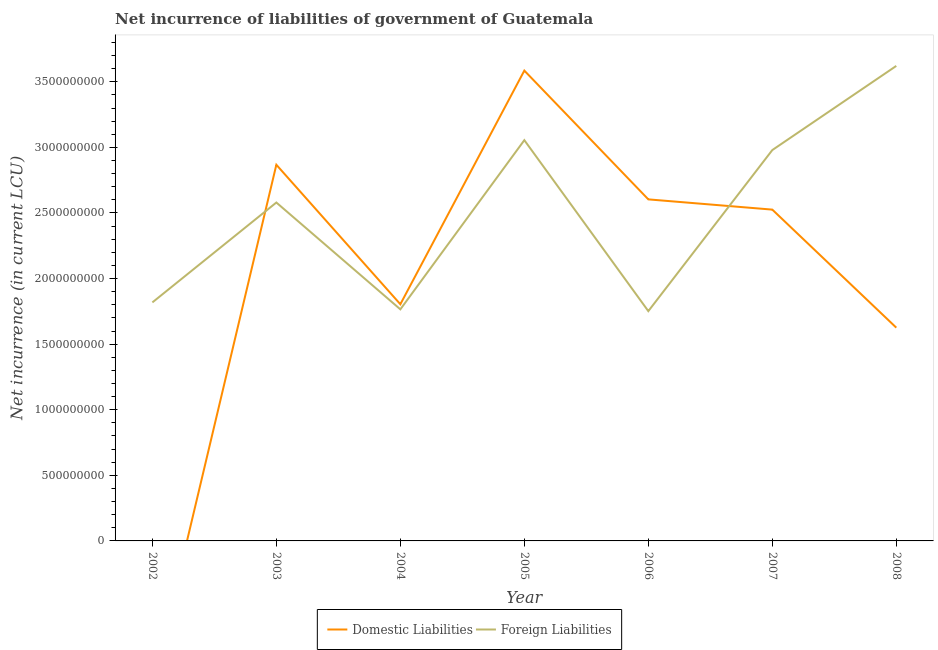How many different coloured lines are there?
Offer a terse response. 2. Does the line corresponding to net incurrence of domestic liabilities intersect with the line corresponding to net incurrence of foreign liabilities?
Make the answer very short. Yes. What is the net incurrence of foreign liabilities in 2005?
Offer a terse response. 3.05e+09. Across all years, what is the maximum net incurrence of domestic liabilities?
Provide a short and direct response. 3.58e+09. Across all years, what is the minimum net incurrence of domestic liabilities?
Your answer should be very brief. 0. In which year was the net incurrence of domestic liabilities maximum?
Your answer should be very brief. 2005. What is the total net incurrence of foreign liabilities in the graph?
Give a very brief answer. 1.76e+1. What is the difference between the net incurrence of domestic liabilities in 2005 and that in 2007?
Provide a short and direct response. 1.06e+09. What is the difference between the net incurrence of foreign liabilities in 2004 and the net incurrence of domestic liabilities in 2005?
Offer a terse response. -1.82e+09. What is the average net incurrence of domestic liabilities per year?
Provide a short and direct response. 2.14e+09. In the year 2003, what is the difference between the net incurrence of domestic liabilities and net incurrence of foreign liabilities?
Offer a very short reply. 2.88e+08. In how many years, is the net incurrence of foreign liabilities greater than 2700000000 LCU?
Make the answer very short. 3. What is the ratio of the net incurrence of domestic liabilities in 2004 to that in 2005?
Make the answer very short. 0.5. Is the net incurrence of foreign liabilities in 2004 less than that in 2006?
Give a very brief answer. No. Is the difference between the net incurrence of domestic liabilities in 2004 and 2007 greater than the difference between the net incurrence of foreign liabilities in 2004 and 2007?
Make the answer very short. Yes. What is the difference between the highest and the second highest net incurrence of domestic liabilities?
Provide a succinct answer. 7.18e+08. What is the difference between the highest and the lowest net incurrence of domestic liabilities?
Your answer should be compact. 3.58e+09. In how many years, is the net incurrence of domestic liabilities greater than the average net incurrence of domestic liabilities taken over all years?
Your answer should be very brief. 4. Is the net incurrence of domestic liabilities strictly less than the net incurrence of foreign liabilities over the years?
Your answer should be very brief. No. How many years are there in the graph?
Provide a succinct answer. 7. Does the graph contain any zero values?
Provide a short and direct response. Yes. Does the graph contain grids?
Provide a short and direct response. No. Where does the legend appear in the graph?
Your answer should be very brief. Bottom center. How many legend labels are there?
Keep it short and to the point. 2. How are the legend labels stacked?
Your answer should be very brief. Horizontal. What is the title of the graph?
Your answer should be compact. Net incurrence of liabilities of government of Guatemala. Does "Goods and services" appear as one of the legend labels in the graph?
Make the answer very short. No. What is the label or title of the X-axis?
Keep it short and to the point. Year. What is the label or title of the Y-axis?
Provide a succinct answer. Net incurrence (in current LCU). What is the Net incurrence (in current LCU) in Foreign Liabilities in 2002?
Your answer should be very brief. 1.82e+09. What is the Net incurrence (in current LCU) of Domestic Liabilities in 2003?
Offer a terse response. 2.87e+09. What is the Net incurrence (in current LCU) in Foreign Liabilities in 2003?
Provide a short and direct response. 2.58e+09. What is the Net incurrence (in current LCU) of Domestic Liabilities in 2004?
Your answer should be compact. 1.80e+09. What is the Net incurrence (in current LCU) in Foreign Liabilities in 2004?
Offer a terse response. 1.77e+09. What is the Net incurrence (in current LCU) of Domestic Liabilities in 2005?
Offer a very short reply. 3.58e+09. What is the Net incurrence (in current LCU) in Foreign Liabilities in 2005?
Offer a very short reply. 3.05e+09. What is the Net incurrence (in current LCU) in Domestic Liabilities in 2006?
Your response must be concise. 2.60e+09. What is the Net incurrence (in current LCU) in Foreign Liabilities in 2006?
Your response must be concise. 1.75e+09. What is the Net incurrence (in current LCU) of Domestic Liabilities in 2007?
Keep it short and to the point. 2.53e+09. What is the Net incurrence (in current LCU) in Foreign Liabilities in 2007?
Offer a very short reply. 2.98e+09. What is the Net incurrence (in current LCU) of Domestic Liabilities in 2008?
Your response must be concise. 1.63e+09. What is the Net incurrence (in current LCU) of Foreign Liabilities in 2008?
Offer a terse response. 3.62e+09. Across all years, what is the maximum Net incurrence (in current LCU) in Domestic Liabilities?
Your answer should be compact. 3.58e+09. Across all years, what is the maximum Net incurrence (in current LCU) in Foreign Liabilities?
Offer a terse response. 3.62e+09. Across all years, what is the minimum Net incurrence (in current LCU) in Foreign Liabilities?
Give a very brief answer. 1.75e+09. What is the total Net incurrence (in current LCU) in Domestic Liabilities in the graph?
Provide a succinct answer. 1.50e+1. What is the total Net incurrence (in current LCU) of Foreign Liabilities in the graph?
Offer a very short reply. 1.76e+1. What is the difference between the Net incurrence (in current LCU) in Foreign Liabilities in 2002 and that in 2003?
Keep it short and to the point. -7.61e+08. What is the difference between the Net incurrence (in current LCU) in Foreign Liabilities in 2002 and that in 2004?
Offer a very short reply. 5.28e+07. What is the difference between the Net incurrence (in current LCU) of Foreign Liabilities in 2002 and that in 2005?
Offer a terse response. -1.24e+09. What is the difference between the Net incurrence (in current LCU) of Foreign Liabilities in 2002 and that in 2006?
Your response must be concise. 6.65e+07. What is the difference between the Net incurrence (in current LCU) of Foreign Liabilities in 2002 and that in 2007?
Your answer should be compact. -1.16e+09. What is the difference between the Net incurrence (in current LCU) in Foreign Liabilities in 2002 and that in 2008?
Your answer should be compact. -1.80e+09. What is the difference between the Net incurrence (in current LCU) of Domestic Liabilities in 2003 and that in 2004?
Your response must be concise. 1.06e+09. What is the difference between the Net incurrence (in current LCU) of Foreign Liabilities in 2003 and that in 2004?
Your answer should be very brief. 8.14e+08. What is the difference between the Net incurrence (in current LCU) of Domestic Liabilities in 2003 and that in 2005?
Give a very brief answer. -7.18e+08. What is the difference between the Net incurrence (in current LCU) in Foreign Liabilities in 2003 and that in 2005?
Make the answer very short. -4.75e+08. What is the difference between the Net incurrence (in current LCU) of Domestic Liabilities in 2003 and that in 2006?
Your answer should be compact. 2.64e+08. What is the difference between the Net incurrence (in current LCU) in Foreign Liabilities in 2003 and that in 2006?
Provide a succinct answer. 8.28e+08. What is the difference between the Net incurrence (in current LCU) in Domestic Liabilities in 2003 and that in 2007?
Your response must be concise. 3.42e+08. What is the difference between the Net incurrence (in current LCU) of Foreign Liabilities in 2003 and that in 2007?
Your answer should be compact. -4.00e+08. What is the difference between the Net incurrence (in current LCU) in Domestic Liabilities in 2003 and that in 2008?
Your response must be concise. 1.24e+09. What is the difference between the Net incurrence (in current LCU) of Foreign Liabilities in 2003 and that in 2008?
Provide a short and direct response. -1.04e+09. What is the difference between the Net incurrence (in current LCU) in Domestic Liabilities in 2004 and that in 2005?
Give a very brief answer. -1.78e+09. What is the difference between the Net incurrence (in current LCU) in Foreign Liabilities in 2004 and that in 2005?
Provide a short and direct response. -1.29e+09. What is the difference between the Net incurrence (in current LCU) in Domestic Liabilities in 2004 and that in 2006?
Ensure brevity in your answer.  -7.99e+08. What is the difference between the Net incurrence (in current LCU) of Foreign Liabilities in 2004 and that in 2006?
Offer a terse response. 1.36e+07. What is the difference between the Net incurrence (in current LCU) in Domestic Liabilities in 2004 and that in 2007?
Provide a short and direct response. -7.21e+08. What is the difference between the Net incurrence (in current LCU) of Foreign Liabilities in 2004 and that in 2007?
Make the answer very short. -1.21e+09. What is the difference between the Net incurrence (in current LCU) of Domestic Liabilities in 2004 and that in 2008?
Provide a short and direct response. 1.79e+08. What is the difference between the Net incurrence (in current LCU) in Foreign Liabilities in 2004 and that in 2008?
Offer a very short reply. -1.86e+09. What is the difference between the Net incurrence (in current LCU) of Domestic Liabilities in 2005 and that in 2006?
Ensure brevity in your answer.  9.82e+08. What is the difference between the Net incurrence (in current LCU) of Foreign Liabilities in 2005 and that in 2006?
Ensure brevity in your answer.  1.30e+09. What is the difference between the Net incurrence (in current LCU) of Domestic Liabilities in 2005 and that in 2007?
Your answer should be very brief. 1.06e+09. What is the difference between the Net incurrence (in current LCU) in Foreign Liabilities in 2005 and that in 2007?
Your response must be concise. 7.54e+07. What is the difference between the Net incurrence (in current LCU) in Domestic Liabilities in 2005 and that in 2008?
Your answer should be compact. 1.96e+09. What is the difference between the Net incurrence (in current LCU) in Foreign Liabilities in 2005 and that in 2008?
Make the answer very short. -5.66e+08. What is the difference between the Net incurrence (in current LCU) in Domestic Liabilities in 2006 and that in 2007?
Your answer should be compact. 7.81e+07. What is the difference between the Net incurrence (in current LCU) in Foreign Liabilities in 2006 and that in 2007?
Your response must be concise. -1.23e+09. What is the difference between the Net incurrence (in current LCU) of Domestic Liabilities in 2006 and that in 2008?
Make the answer very short. 9.78e+08. What is the difference between the Net incurrence (in current LCU) in Foreign Liabilities in 2006 and that in 2008?
Provide a succinct answer. -1.87e+09. What is the difference between the Net incurrence (in current LCU) in Domestic Liabilities in 2007 and that in 2008?
Give a very brief answer. 9.00e+08. What is the difference between the Net incurrence (in current LCU) of Foreign Liabilities in 2007 and that in 2008?
Keep it short and to the point. -6.41e+08. What is the difference between the Net incurrence (in current LCU) of Domestic Liabilities in 2003 and the Net incurrence (in current LCU) of Foreign Liabilities in 2004?
Your answer should be very brief. 1.10e+09. What is the difference between the Net incurrence (in current LCU) of Domestic Liabilities in 2003 and the Net incurrence (in current LCU) of Foreign Liabilities in 2005?
Ensure brevity in your answer.  -1.87e+08. What is the difference between the Net incurrence (in current LCU) of Domestic Liabilities in 2003 and the Net incurrence (in current LCU) of Foreign Liabilities in 2006?
Your response must be concise. 1.12e+09. What is the difference between the Net incurrence (in current LCU) in Domestic Liabilities in 2003 and the Net incurrence (in current LCU) in Foreign Liabilities in 2007?
Make the answer very short. -1.12e+08. What is the difference between the Net incurrence (in current LCU) in Domestic Liabilities in 2003 and the Net incurrence (in current LCU) in Foreign Liabilities in 2008?
Your response must be concise. -7.54e+08. What is the difference between the Net incurrence (in current LCU) in Domestic Liabilities in 2004 and the Net incurrence (in current LCU) in Foreign Liabilities in 2005?
Offer a very short reply. -1.25e+09. What is the difference between the Net incurrence (in current LCU) of Domestic Liabilities in 2004 and the Net incurrence (in current LCU) of Foreign Liabilities in 2006?
Offer a terse response. 5.25e+07. What is the difference between the Net incurrence (in current LCU) in Domestic Liabilities in 2004 and the Net incurrence (in current LCU) in Foreign Liabilities in 2007?
Offer a very short reply. -1.18e+09. What is the difference between the Net incurrence (in current LCU) in Domestic Liabilities in 2004 and the Net incurrence (in current LCU) in Foreign Liabilities in 2008?
Provide a succinct answer. -1.82e+09. What is the difference between the Net incurrence (in current LCU) of Domestic Liabilities in 2005 and the Net incurrence (in current LCU) of Foreign Liabilities in 2006?
Offer a terse response. 1.83e+09. What is the difference between the Net incurrence (in current LCU) in Domestic Liabilities in 2005 and the Net incurrence (in current LCU) in Foreign Liabilities in 2007?
Make the answer very short. 6.06e+08. What is the difference between the Net incurrence (in current LCU) in Domestic Liabilities in 2005 and the Net incurrence (in current LCU) in Foreign Liabilities in 2008?
Give a very brief answer. -3.58e+07. What is the difference between the Net incurrence (in current LCU) in Domestic Liabilities in 2006 and the Net incurrence (in current LCU) in Foreign Liabilities in 2007?
Offer a terse response. -3.76e+08. What is the difference between the Net incurrence (in current LCU) of Domestic Liabilities in 2006 and the Net incurrence (in current LCU) of Foreign Liabilities in 2008?
Provide a short and direct response. -1.02e+09. What is the difference between the Net incurrence (in current LCU) of Domestic Liabilities in 2007 and the Net incurrence (in current LCU) of Foreign Liabilities in 2008?
Provide a succinct answer. -1.10e+09. What is the average Net incurrence (in current LCU) of Domestic Liabilities per year?
Offer a terse response. 2.14e+09. What is the average Net incurrence (in current LCU) of Foreign Liabilities per year?
Your answer should be very brief. 2.51e+09. In the year 2003, what is the difference between the Net incurrence (in current LCU) in Domestic Liabilities and Net incurrence (in current LCU) in Foreign Liabilities?
Your response must be concise. 2.88e+08. In the year 2004, what is the difference between the Net incurrence (in current LCU) of Domestic Liabilities and Net incurrence (in current LCU) of Foreign Liabilities?
Provide a succinct answer. 3.89e+07. In the year 2005, what is the difference between the Net incurrence (in current LCU) in Domestic Liabilities and Net incurrence (in current LCU) in Foreign Liabilities?
Keep it short and to the point. 5.30e+08. In the year 2006, what is the difference between the Net incurrence (in current LCU) in Domestic Liabilities and Net incurrence (in current LCU) in Foreign Liabilities?
Your answer should be compact. 8.52e+08. In the year 2007, what is the difference between the Net incurrence (in current LCU) in Domestic Liabilities and Net incurrence (in current LCU) in Foreign Liabilities?
Offer a very short reply. -4.54e+08. In the year 2008, what is the difference between the Net incurrence (in current LCU) in Domestic Liabilities and Net incurrence (in current LCU) in Foreign Liabilities?
Your response must be concise. -2.00e+09. What is the ratio of the Net incurrence (in current LCU) of Foreign Liabilities in 2002 to that in 2003?
Your response must be concise. 0.7. What is the ratio of the Net incurrence (in current LCU) of Foreign Liabilities in 2002 to that in 2004?
Provide a short and direct response. 1.03. What is the ratio of the Net incurrence (in current LCU) of Foreign Liabilities in 2002 to that in 2005?
Offer a very short reply. 0.6. What is the ratio of the Net incurrence (in current LCU) of Foreign Liabilities in 2002 to that in 2006?
Keep it short and to the point. 1.04. What is the ratio of the Net incurrence (in current LCU) of Foreign Liabilities in 2002 to that in 2007?
Offer a very short reply. 0.61. What is the ratio of the Net incurrence (in current LCU) in Foreign Liabilities in 2002 to that in 2008?
Your answer should be compact. 0.5. What is the ratio of the Net incurrence (in current LCU) in Domestic Liabilities in 2003 to that in 2004?
Make the answer very short. 1.59. What is the ratio of the Net incurrence (in current LCU) of Foreign Liabilities in 2003 to that in 2004?
Give a very brief answer. 1.46. What is the ratio of the Net incurrence (in current LCU) of Domestic Liabilities in 2003 to that in 2005?
Give a very brief answer. 0.8. What is the ratio of the Net incurrence (in current LCU) of Foreign Liabilities in 2003 to that in 2005?
Provide a succinct answer. 0.84. What is the ratio of the Net incurrence (in current LCU) in Domestic Liabilities in 2003 to that in 2006?
Give a very brief answer. 1.1. What is the ratio of the Net incurrence (in current LCU) of Foreign Liabilities in 2003 to that in 2006?
Offer a very short reply. 1.47. What is the ratio of the Net incurrence (in current LCU) in Domestic Liabilities in 2003 to that in 2007?
Provide a succinct answer. 1.14. What is the ratio of the Net incurrence (in current LCU) in Foreign Liabilities in 2003 to that in 2007?
Make the answer very short. 0.87. What is the ratio of the Net incurrence (in current LCU) in Domestic Liabilities in 2003 to that in 2008?
Ensure brevity in your answer.  1.76. What is the ratio of the Net incurrence (in current LCU) in Foreign Liabilities in 2003 to that in 2008?
Give a very brief answer. 0.71. What is the ratio of the Net incurrence (in current LCU) of Domestic Liabilities in 2004 to that in 2005?
Your answer should be compact. 0.5. What is the ratio of the Net incurrence (in current LCU) in Foreign Liabilities in 2004 to that in 2005?
Your answer should be very brief. 0.58. What is the ratio of the Net incurrence (in current LCU) in Domestic Liabilities in 2004 to that in 2006?
Provide a short and direct response. 0.69. What is the ratio of the Net incurrence (in current LCU) in Domestic Liabilities in 2004 to that in 2007?
Provide a short and direct response. 0.71. What is the ratio of the Net incurrence (in current LCU) of Foreign Liabilities in 2004 to that in 2007?
Make the answer very short. 0.59. What is the ratio of the Net incurrence (in current LCU) in Domestic Liabilities in 2004 to that in 2008?
Provide a succinct answer. 1.11. What is the ratio of the Net incurrence (in current LCU) of Foreign Liabilities in 2004 to that in 2008?
Your answer should be compact. 0.49. What is the ratio of the Net incurrence (in current LCU) of Domestic Liabilities in 2005 to that in 2006?
Offer a very short reply. 1.38. What is the ratio of the Net incurrence (in current LCU) of Foreign Liabilities in 2005 to that in 2006?
Give a very brief answer. 1.74. What is the ratio of the Net incurrence (in current LCU) of Domestic Liabilities in 2005 to that in 2007?
Your answer should be compact. 1.42. What is the ratio of the Net incurrence (in current LCU) in Foreign Liabilities in 2005 to that in 2007?
Your answer should be very brief. 1.03. What is the ratio of the Net incurrence (in current LCU) in Domestic Liabilities in 2005 to that in 2008?
Keep it short and to the point. 2.21. What is the ratio of the Net incurrence (in current LCU) of Foreign Liabilities in 2005 to that in 2008?
Your answer should be very brief. 0.84. What is the ratio of the Net incurrence (in current LCU) in Domestic Liabilities in 2006 to that in 2007?
Your answer should be very brief. 1.03. What is the ratio of the Net incurrence (in current LCU) of Foreign Liabilities in 2006 to that in 2007?
Offer a very short reply. 0.59. What is the ratio of the Net incurrence (in current LCU) of Domestic Liabilities in 2006 to that in 2008?
Offer a very short reply. 1.6. What is the ratio of the Net incurrence (in current LCU) in Foreign Liabilities in 2006 to that in 2008?
Ensure brevity in your answer.  0.48. What is the ratio of the Net incurrence (in current LCU) of Domestic Liabilities in 2007 to that in 2008?
Keep it short and to the point. 1.55. What is the ratio of the Net incurrence (in current LCU) in Foreign Liabilities in 2007 to that in 2008?
Ensure brevity in your answer.  0.82. What is the difference between the highest and the second highest Net incurrence (in current LCU) of Domestic Liabilities?
Your answer should be very brief. 7.18e+08. What is the difference between the highest and the second highest Net incurrence (in current LCU) in Foreign Liabilities?
Provide a succinct answer. 5.66e+08. What is the difference between the highest and the lowest Net incurrence (in current LCU) in Domestic Liabilities?
Your answer should be compact. 3.58e+09. What is the difference between the highest and the lowest Net incurrence (in current LCU) in Foreign Liabilities?
Ensure brevity in your answer.  1.87e+09. 